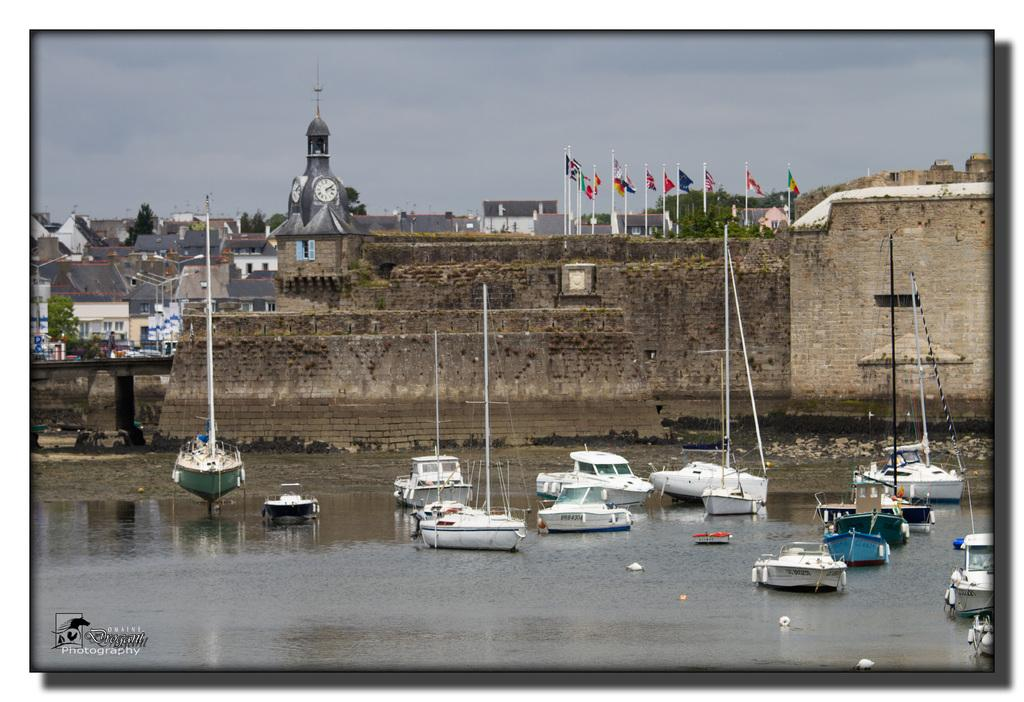What is happening on the water in the image? There are boats on the water in the image. What type of structures can be seen in the image? There are walls, poles, flags, and buildings visible in the image. What type of vegetation is present in the image? There are trees in the image. What else can be seen in the image that is not specified? There are some unspecified objects in the image. What is visible in the background of the image? The sky is visible in the background of the image. Can you tell me how many monkeys are sitting on the floor in the image? There are no monkeys or floors present in the image; it features boats on the water, walls, poles, flags, buildings, trees, and unspecified objects. How many cows can be seen grazing in the image? There are no cows present in the image. 